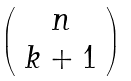<formula> <loc_0><loc_0><loc_500><loc_500>\left ( \begin{array} { c } { n } \\ { k + 1 } \end{array} \right )</formula> 